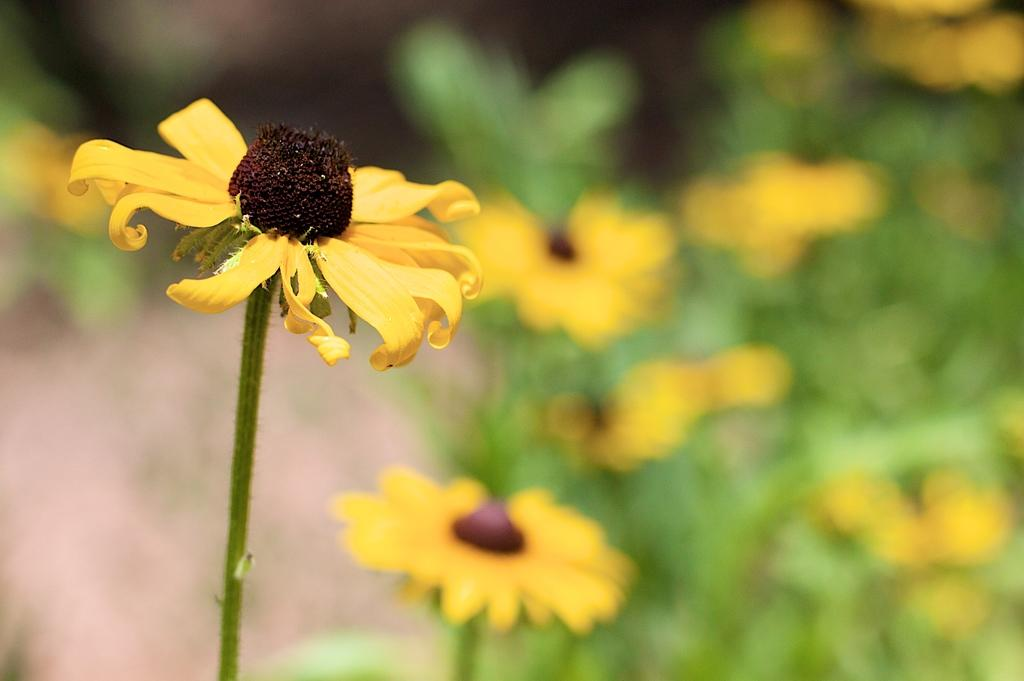What is the main subject of the image? There is a flower with a stem in the image. Can you describe the background of the image? The background of the image has a blurred view. What else can be seen on the right side of the image? There are many plants with flowers on the right side of the image. Can you tell me how many bats are hanging from the flower in the image? There are no bats present in the image; it features a flower with a stem and other plants with flowers. What type of connection can be seen between the flower and the cup in the image? There is no cup present in the image, so it is not possible to determine any connection between the flower and a cup. 